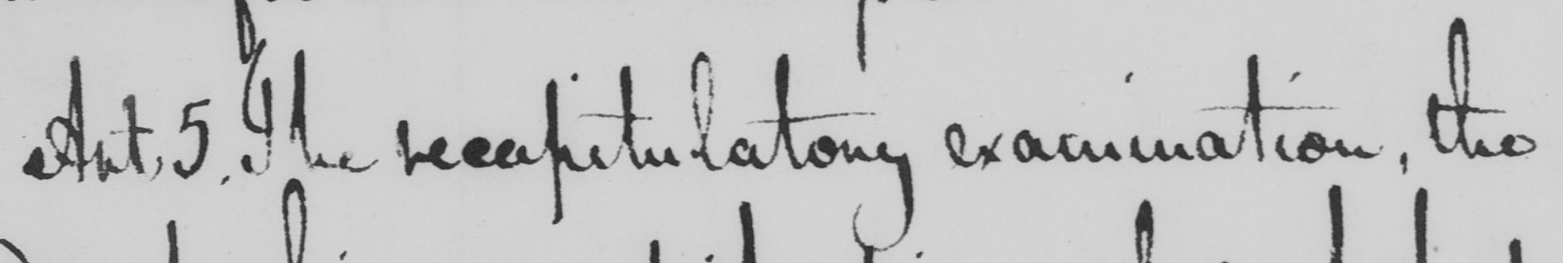Can you tell me what this handwritten text says? Art . 5 . The recapitulatory examination , the 